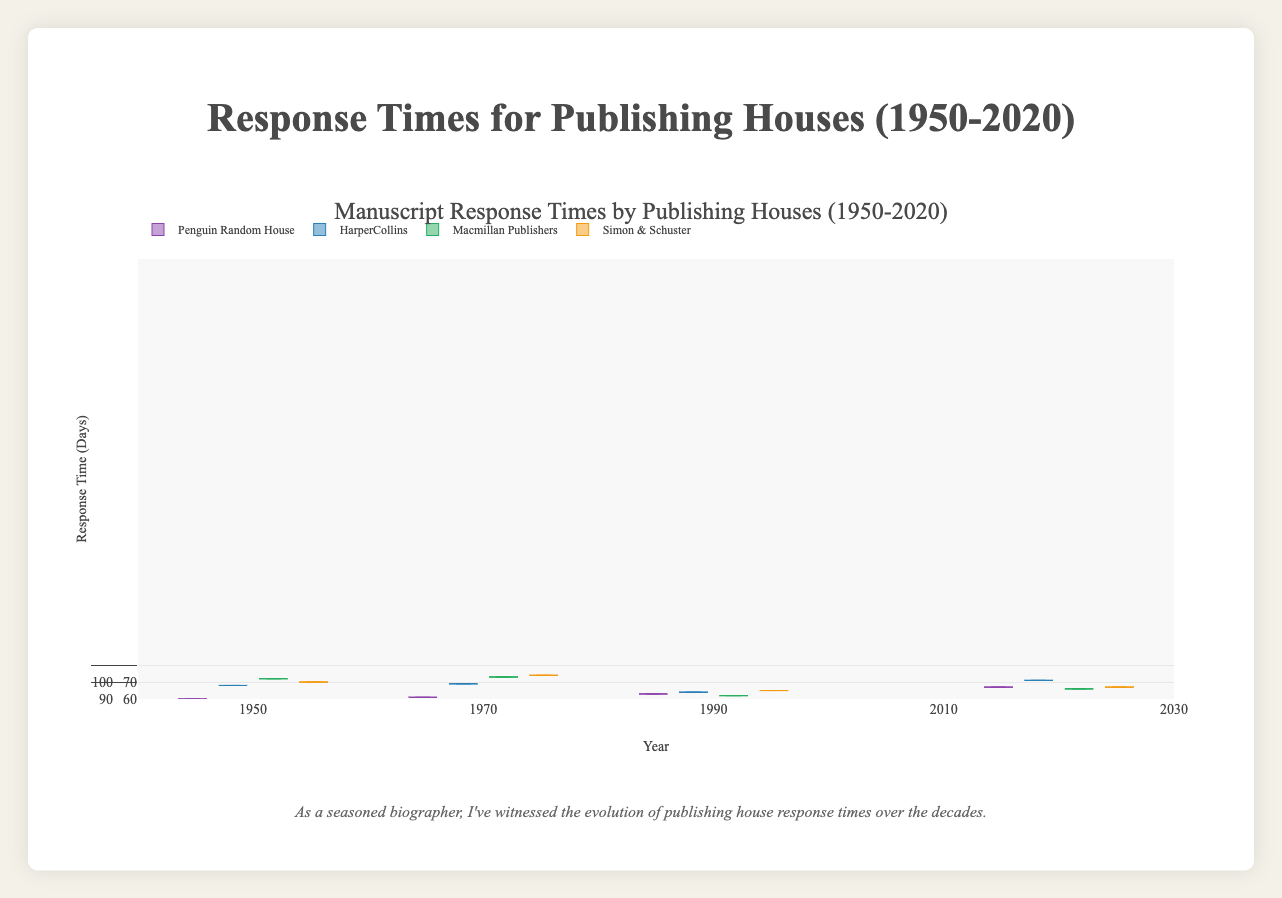What is the title of the plot? The plot's title is displayed at the top of the figure, which provides an overview of what the plot is about.
Answer: Manuscript Response Times by Publishing Houses (1950-2020) Which publishing house had the slowest response time in 1950? By examining the median response times in the plot for the year 1950, the highest median can be identified. HarperCollins has the highest median value.
Answer: HarperCollins How did the median response times for Penguin Random House change from 1950 to 2020? Observing the location of the median line in the box plots for Penguin Random House across the different years, there is a clear decrease in the median response time from 1950 (150 days) to 2020 (45 days).
Answer: Decreased from ~150 days to ~45 days Compare the overall range of response times for Simon & Schuster between 1950 and 2020. What do you observe? By analyzing the length of the whiskers and the range of the boxes, in 1950 the range was from 100 to 210 days, while in 2020 it was from 20 to 100 days. This shows a significant reduction in the range of response times over time.
Answer: The range decreased significantly Which year had the shortest minimum response time across all publishing houses? The plot can be checked for the lowest values represented by the bottom whiskers or points. In 2020, all publishing houses have the lowest minimum response times.
Answer: 2020 How do the interquartile ranges (IQR) for HarperCollins change from 1950 to 2020? Observing the size of the boxes for HarperCollins over the years, the IQR can be seen to shrink from 150-80=70 days in 1950 to 80-40=40 days in 2020, indicating a narrower range of typical response times.
Answer: Decrease from 70 days to 40 days Which publishing house had the greatest reduction in maximum response time from 1950 to 2020? Compare the top whisker endpoints for each publishing house in 1950 and 2020, observing the greatest reduction. HarperCollins reduced from 250 days in 1950 to 100 days in 2020, which is the largest reduction.
Answer: HarperCollins What is the median response time for Macmillan Publishers in 1990? The median value for Macmillan Publishers in 1990 is the line in the middle of the box, which is around 80 days.
Answer: 80 days In which year were the response times for all publishing houses closest to each other? The goal is to identify the year where the medians and the overall range of each house’s box overlaps the most. In 2020, the medians and the overall ranges of all houses are relatively close to each other, showing that response times became more standardized across publishers in 2020.
Answer: 2020 Which years show a noticeable decrease in response times for all publishing houses? By looking at the changes in the boxes and whiskers, noticeable decreases appear between 1970 and 1990 and then again significantly to 2020 for all publishing houses, indicating ongoing improvements in manuscript response times.
Answer: 1990 and 2020 